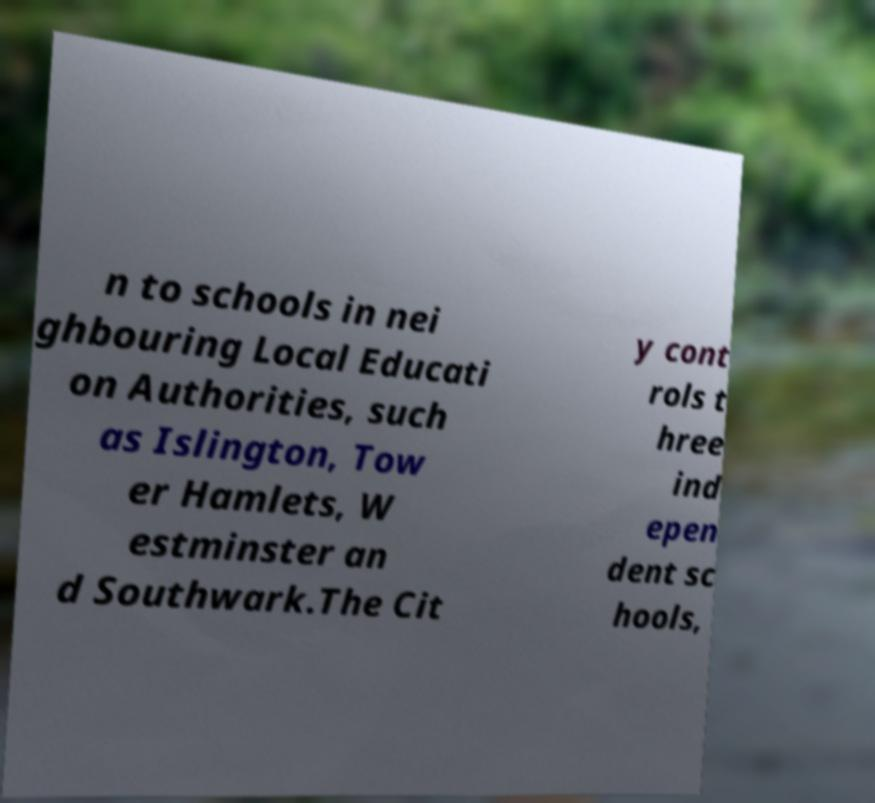Please read and relay the text visible in this image. What does it say? n to schools in nei ghbouring Local Educati on Authorities, such as Islington, Tow er Hamlets, W estminster an d Southwark.The Cit y cont rols t hree ind epen dent sc hools, 